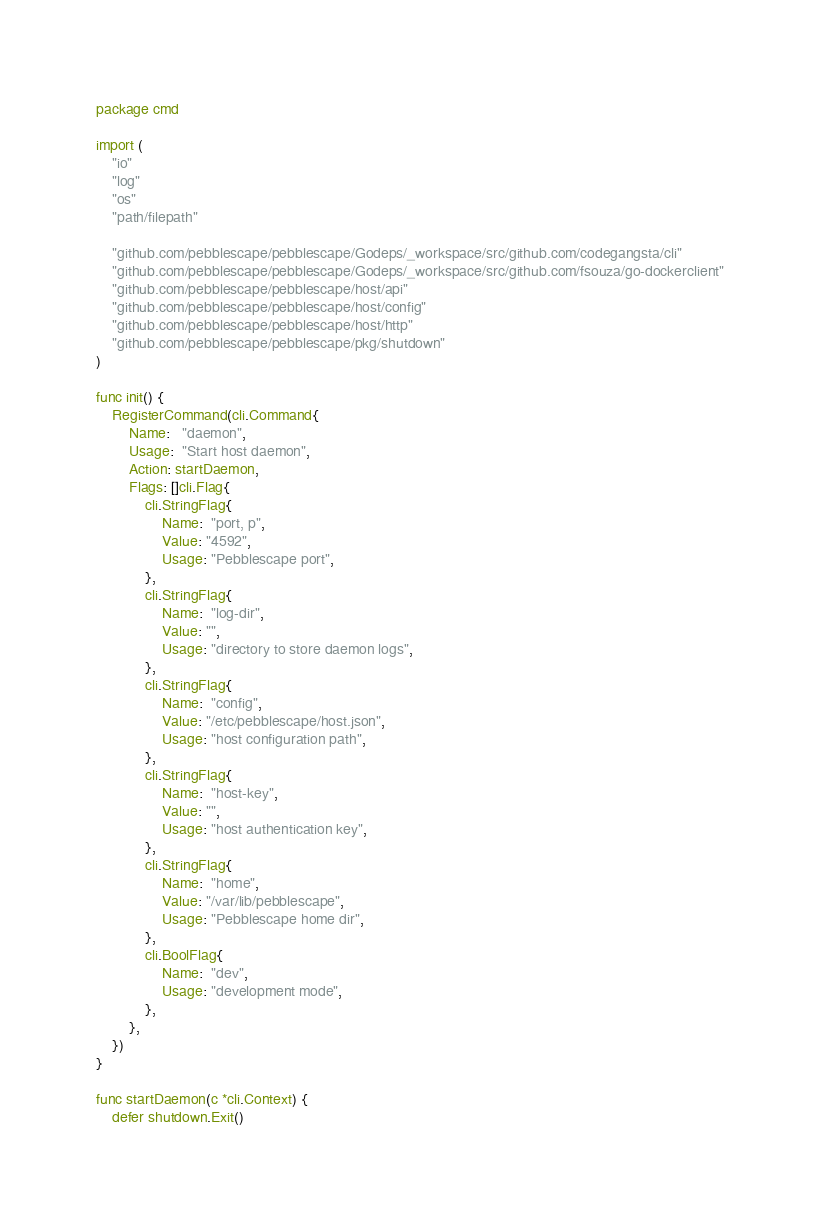Convert code to text. <code><loc_0><loc_0><loc_500><loc_500><_Go_>package cmd

import (
	"io"
	"log"
	"os"
	"path/filepath"

	"github.com/pebblescape/pebblescape/Godeps/_workspace/src/github.com/codegangsta/cli"
	"github.com/pebblescape/pebblescape/Godeps/_workspace/src/github.com/fsouza/go-dockerclient"
	"github.com/pebblescape/pebblescape/host/api"
	"github.com/pebblescape/pebblescape/host/config"
	"github.com/pebblescape/pebblescape/host/http"
	"github.com/pebblescape/pebblescape/pkg/shutdown"
)

func init() {
	RegisterCommand(cli.Command{
		Name:   "daemon",
		Usage:  "Start host daemon",
		Action: startDaemon,
		Flags: []cli.Flag{
			cli.StringFlag{
				Name:  "port, p",
				Value: "4592",
				Usage: "Pebblescape port",
			},
			cli.StringFlag{
				Name:  "log-dir",
				Value: "",
				Usage: "directory to store daemon logs",
			},
			cli.StringFlag{
				Name:  "config",
				Value: "/etc/pebblescape/host.json",
				Usage: "host configuration path",
			},
			cli.StringFlag{
				Name:  "host-key",
				Value: "",
				Usage: "host authentication key",
			},
			cli.StringFlag{
				Name:  "home",
				Value: "/var/lib/pebblescape",
				Usage: "Pebblescape home dir",
			},
			cli.BoolFlag{
				Name:  "dev",
				Usage: "development mode",
			},
		},
	})
}

func startDaemon(c *cli.Context) {
	defer shutdown.Exit()
</code> 